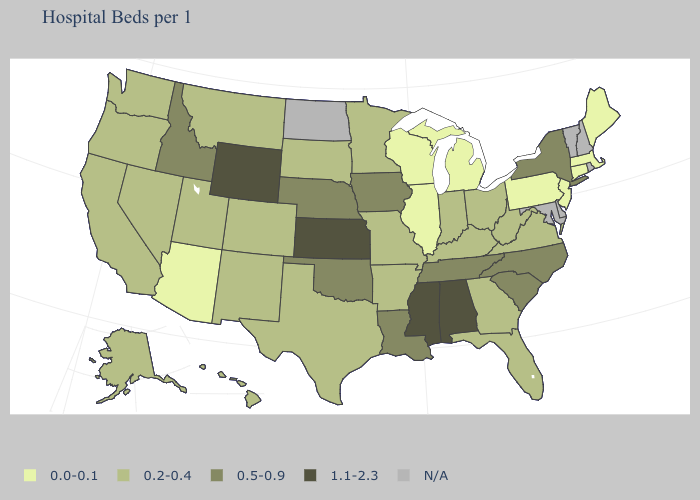Does Wyoming have the highest value in the USA?
Answer briefly. Yes. Among the states that border Virginia , which have the lowest value?
Concise answer only. Kentucky, West Virginia. Name the states that have a value in the range 0.2-0.4?
Quick response, please. Alaska, Arkansas, California, Colorado, Florida, Georgia, Hawaii, Indiana, Kentucky, Minnesota, Missouri, Montana, Nevada, New Mexico, Ohio, Oregon, South Dakota, Texas, Utah, Virginia, Washington, West Virginia. Name the states that have a value in the range N/A?
Be succinct. Delaware, Maryland, New Hampshire, North Dakota, Rhode Island, Vermont. What is the value of Oklahoma?
Short answer required. 0.5-0.9. How many symbols are there in the legend?
Short answer required. 5. Which states have the lowest value in the USA?
Answer briefly. Arizona, Connecticut, Illinois, Maine, Massachusetts, Michigan, New Jersey, Pennsylvania, Wisconsin. Which states have the highest value in the USA?
Short answer required. Alabama, Kansas, Mississippi, Wyoming. What is the value of Montana?
Give a very brief answer. 0.2-0.4. Which states have the highest value in the USA?
Quick response, please. Alabama, Kansas, Mississippi, Wyoming. Among the states that border Vermont , does New York have the highest value?
Short answer required. Yes. 